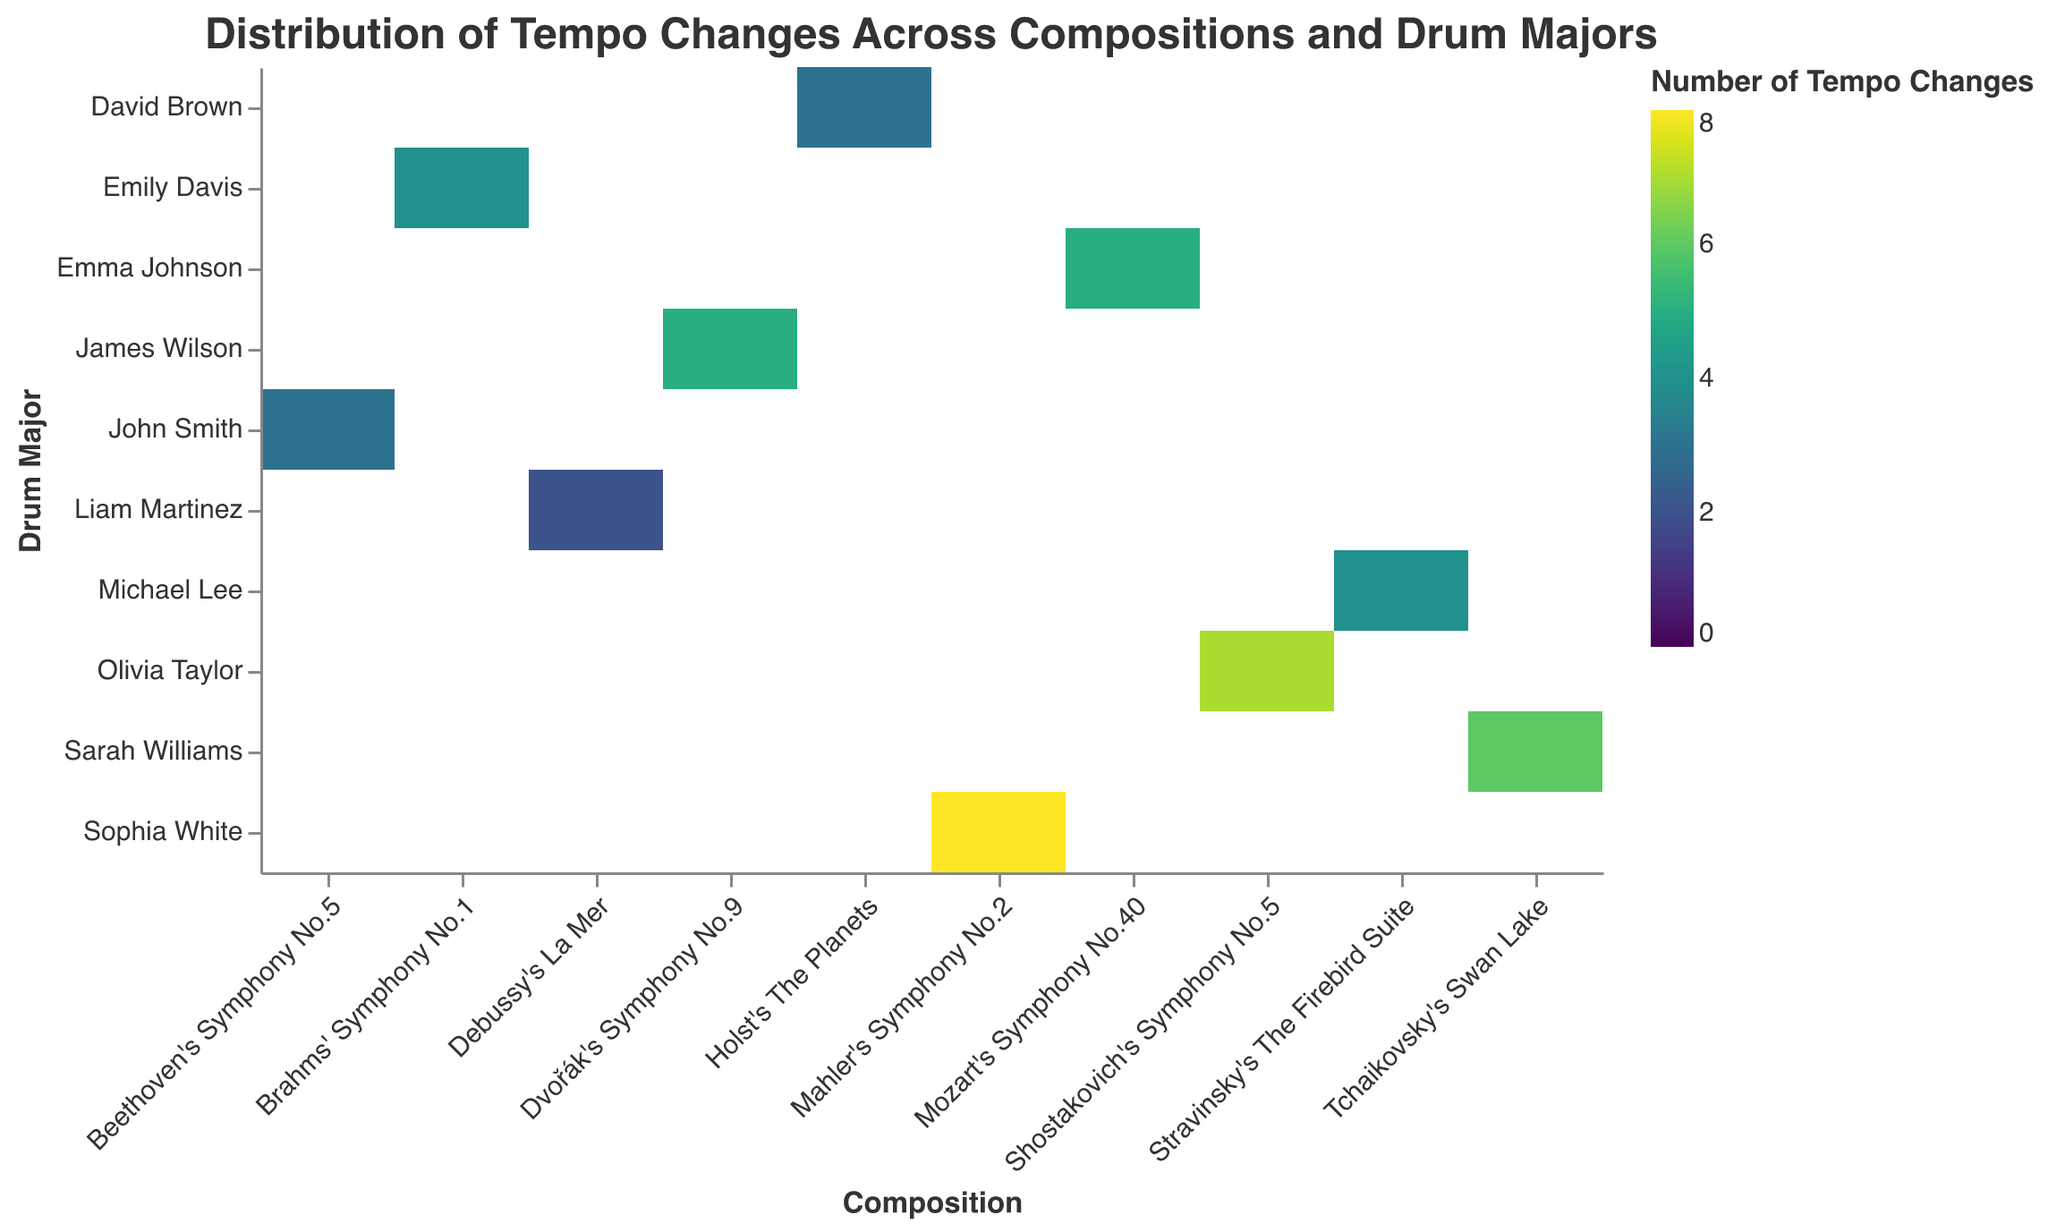Which Drum Major conducted the composition with the most tempo changes? Look at the heatmap for the darkest cell which indicates the highest number of tempo changes. Identify the Drum Major corresponding to that cell.
Answer: Sophia White How many compositions have more than 5 tempo changes? Count the number of cells in the heatmap with a color indicating more than 5 tempo changes. There should be two such cells.
Answer: 2 Which compositions have the same number of tempo changes under different Drum Majors? Find cells with the same color intensity indicating equal values for tempo changes and note the compositions. For example, "Brahms' Symphony No.1" under Emily Davis and "Stravinsky's The Firebird Suite" under Michael Lee both have 4 tempo changes.
Answer: "Brahms' Symphony No.1", "Stravinsky's The Firebird Suite" What is the average number of tempo changes for compositions led by James Wilson and Sarah Williams? Identify the cells for James Wilson and Sarah Williams, sum their values (5 for James Wilson and 6 for Sarah Williams), and divide by 2. (5 + 6) / 2 = 5.5
Answer: 5.5 Which Drum Major has more slowdowns than speedups, and in which compositions? Compare the "Slowdowns" and "Speedups" values in the heatmap's tooltip. Drum Majors with more slowdowns than speedups are John Smith ("Beethoven's Symphony No.5") and Olivia Taylor ("Shostakovich's Symphony No.5").
Answer: John Smith, "Beethoven's Symphony No.5" Which Drum Major conducted the composition with the fewest tempo changes? Look for the lightest-colored cell in the heatmap which indicates the fewest tempo changes, then identify the Drum Major.
Answer: Liam Martinez How many Drum Majors conducted compositions with exactly 4 tempo changes? Count the cells in the heatmap with the color representing 4 tempo changes. There are three such cells.
Answer: 3 Which compositions are conducted by Michael Lee, and what are the tempo changes for each? Identify Michael Lee in the y-axis and note the compositions corresponding to his cells from the x-axis, along with the number of tempo changes. Michael Lee conducted "Stravinsky's The Firebird Suite" with 4 tempo changes.
Answer: "Stravinsky's The Firebird Suite", 4 